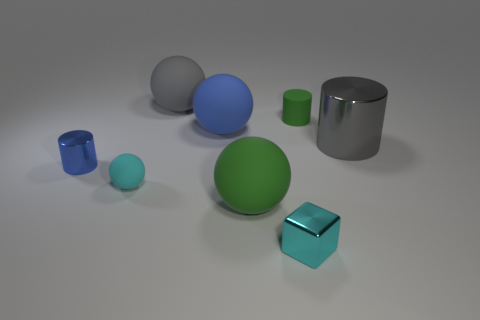What is the big cylinder made of?
Ensure brevity in your answer.  Metal. What color is the tiny matte thing that is behind the tiny shiny cylinder?
Your answer should be very brief. Green. How many big objects are either matte cylinders or yellow blocks?
Provide a succinct answer. 0. Do the big thing that is in front of the tiny cyan sphere and the matte thing that is right of the small cyan cube have the same color?
Your answer should be very brief. Yes. What number of other things are there of the same color as the rubber cylinder?
Provide a short and direct response. 1. What number of red objects are either matte things or tiny shiny objects?
Your answer should be compact. 0. Does the gray shiny thing have the same shape as the small blue thing left of the tiny rubber sphere?
Make the answer very short. Yes. What shape is the small green thing?
Give a very brief answer. Cylinder. There is a green object that is the same size as the blue matte ball; what is its material?
Give a very brief answer. Rubber. What number of objects are small rubber objects or green objects behind the cyan matte thing?
Your answer should be very brief. 2. 